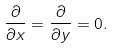Convert formula to latex. <formula><loc_0><loc_0><loc_500><loc_500>\frac { \partial } { \partial x } = \frac { \partial } { \partial y } = 0 .</formula> 